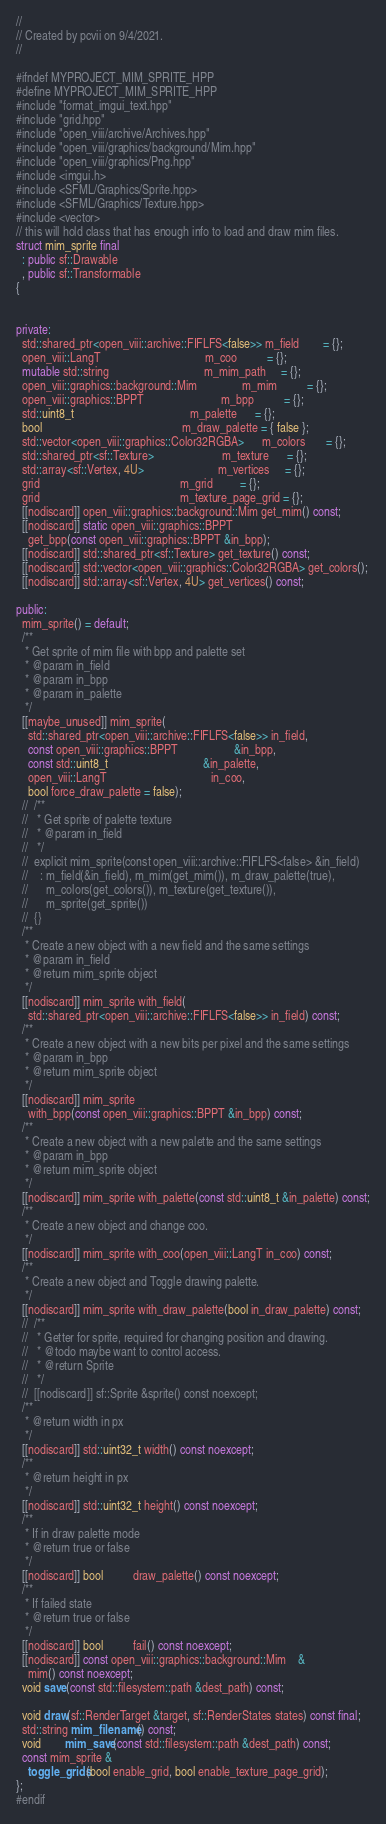Convert code to text. <code><loc_0><loc_0><loc_500><loc_500><_C++_>//
// Created by pcvii on 9/4/2021.
//

#ifndef MYPROJECT_MIM_SPRITE_HPP
#define MYPROJECT_MIM_SPRITE_HPP
#include "format_imgui_text.hpp"
#include "grid.hpp"
#include "open_viii/archive/Archives.hpp"
#include "open_viii/graphics/background/Mim.hpp"
#include "open_viii/graphics/Png.hpp"
#include <imgui.h>
#include <SFML/Graphics/Sprite.hpp>
#include <SFML/Graphics/Texture.hpp>
#include <vector>
// this will hold class that has enough info to load and draw mim files.
struct mim_sprite final
  : public sf::Drawable
  , public sf::Transformable
{


private:
  std::shared_ptr<open_viii::archive::FIFLFS<false>> m_field        = {};
  open_viii::LangT                                   m_coo          = {};
  mutable std::string                                m_mim_path     = {};
  open_viii::graphics::background::Mim               m_mim          = {};
  open_viii::graphics::BPPT                          m_bpp          = {};
  std::uint8_t                                       m_palette      = {};
  bool                                               m_draw_palette = { false };
  std::vector<open_viii::graphics::Color32RGBA>      m_colors       = {};
  std::shared_ptr<sf::Texture>                       m_texture      = {};
  std::array<sf::Vertex, 4U>                         m_vertices     = {};
  grid                                               m_grid         = {};
  grid                                               m_texture_page_grid = {};
  [[nodiscard]] open_viii::graphics::background::Mim get_mim() const;
  [[nodiscard]] static open_viii::graphics::BPPT
    get_bpp(const open_viii::graphics::BPPT &in_bpp);
  [[nodiscard]] std::shared_ptr<sf::Texture> get_texture() const;
  [[nodiscard]] std::vector<open_viii::graphics::Color32RGBA> get_colors();
  [[nodiscard]] std::array<sf::Vertex, 4U> get_vertices() const;

public:
  mim_sprite() = default;
  /**
   * Get sprite of mim file with bpp and palette set
   * @param in_field
   * @param in_bpp
   * @param in_palette
   */
  [[maybe_unused]] mim_sprite(
    std::shared_ptr<open_viii::archive::FIFLFS<false>> in_field,
    const open_viii::graphics::BPPT                   &in_bpp,
    const std::uint8_t                                &in_palette,
    open_viii::LangT                                   in_coo,
    bool force_draw_palette = false);
  //  /**
  //   * Get sprite of palette texture
  //   * @param in_field
  //   */
  //  explicit mim_sprite(const open_viii::archive::FIFLFS<false> &in_field)
  //    : m_field(&in_field), m_mim(get_mim()), m_draw_palette(true),
  //      m_colors(get_colors()), m_texture(get_texture()),
  //      m_sprite(get_sprite())
  //  {}
  /**
   * Create a new object with a new field and the same settings
   * @param in_field
   * @return mim_sprite object
   */
  [[nodiscard]] mim_sprite with_field(
    std::shared_ptr<open_viii::archive::FIFLFS<false>> in_field) const;
  /**
   * Create a new object with a new bits per pixel and the same settings
   * @param in_bpp
   * @return mim_sprite object
   */
  [[nodiscard]] mim_sprite
    with_bpp(const open_viii::graphics::BPPT &in_bpp) const;
  /**
   * Create a new object with a new palette and the same settings
   * @param in_bpp
   * @return mim_sprite object
   */
  [[nodiscard]] mim_sprite with_palette(const std::uint8_t &in_palette) const;
  /**
   * Create a new object and change coo.
   */
  [[nodiscard]] mim_sprite with_coo(open_viii::LangT in_coo) const;
  /**
   * Create a new object and Toggle drawing palette.
   */
  [[nodiscard]] mim_sprite with_draw_palette(bool in_draw_palette) const;
  //  /**
  //   * Getter for sprite, required for changing position and drawing.
  //   * @todo maybe want to control access.
  //   * @return Sprite
  //   */
  //  [[nodiscard]] sf::Sprite &sprite() const noexcept;
  /**
   * @return width in px
   */
  [[nodiscard]] std::uint32_t width() const noexcept;
  /**
   * @return height in px
   */
  [[nodiscard]] std::uint32_t height() const noexcept;
  /**
   * If in draw palette mode
   * @return true or false
   */
  [[nodiscard]] bool          draw_palette() const noexcept;
  /**
   * If failed state
   * @return true or false
   */
  [[nodiscard]] bool          fail() const noexcept;
  [[nodiscard]] const open_viii::graphics::background::Mim    &
    mim() const noexcept;
  void save(const std::filesystem::path &dest_path) const;

  void draw(sf::RenderTarget &target, sf::RenderStates states) const final;
  std::string mim_filename() const;
  void        mim_save(const std::filesystem::path &dest_path) const;
  const mim_sprite &
    toggle_grids(bool enable_grid, bool enable_texture_page_grid);
};
#endif</code> 